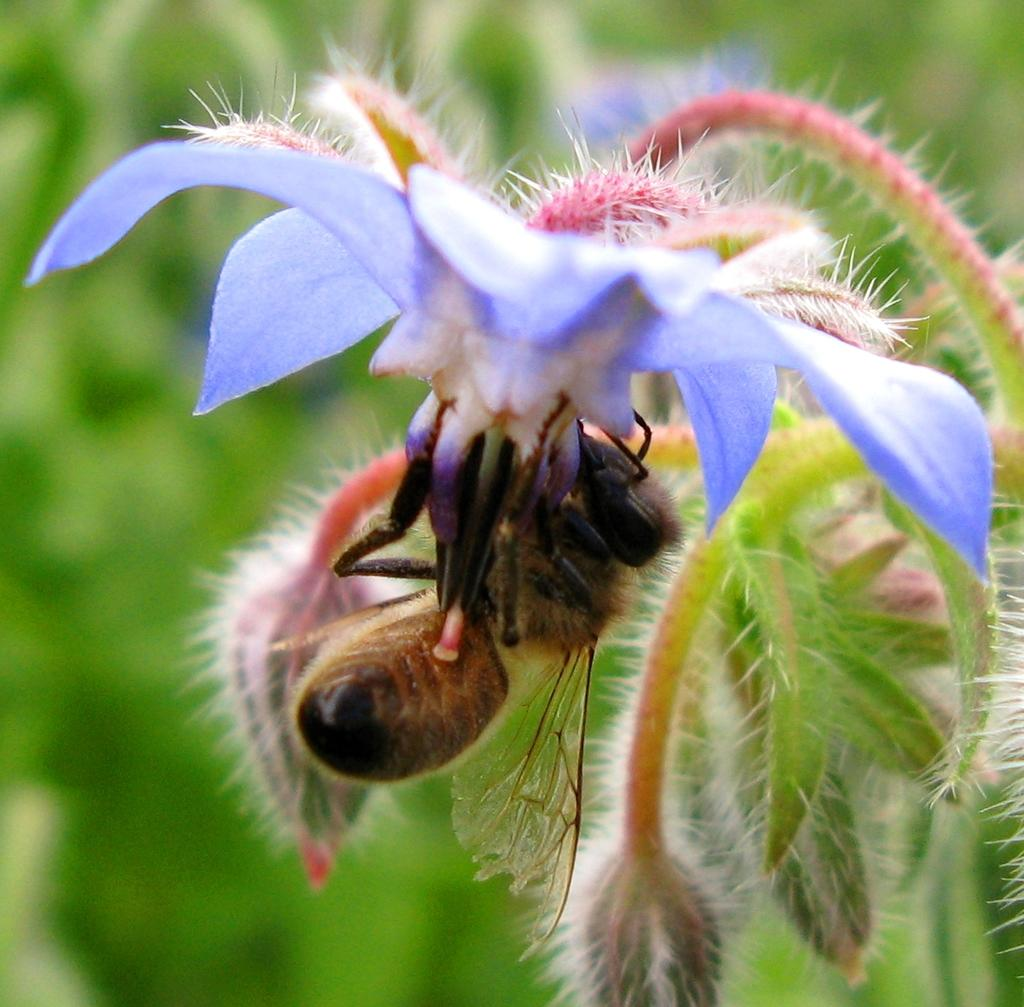What is the main subject of the image? The main subject of the image is a stem with a flower. Are there any additional features on the stem? Yes, there are buds on the stem. What can be seen on the flower? There is an insect on the flower. How would you describe the background of the image? The background of the image is green and blurred. How many eggs are visible in the image? There are no eggs present in the image. What type of rake is being used to roll the flower in the image? There is no rake or rolling action in the image; it features a stem with a flower and an insect. 